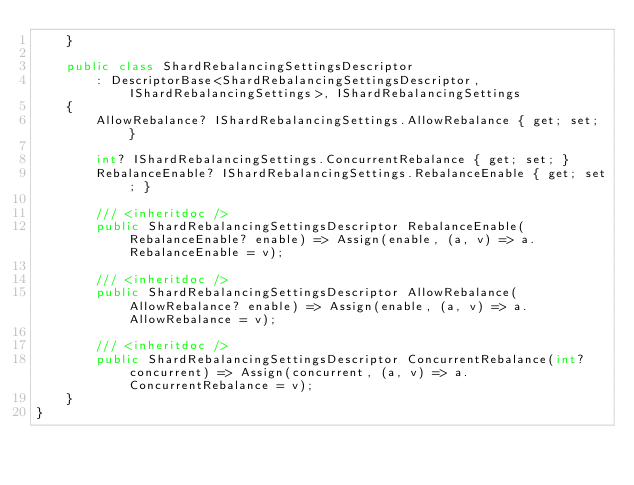<code> <loc_0><loc_0><loc_500><loc_500><_C#_>	}

	public class ShardRebalancingSettingsDescriptor
		: DescriptorBase<ShardRebalancingSettingsDescriptor, IShardRebalancingSettings>, IShardRebalancingSettings
	{
		AllowRebalance? IShardRebalancingSettings.AllowRebalance { get; set; }

		int? IShardRebalancingSettings.ConcurrentRebalance { get; set; }
		RebalanceEnable? IShardRebalancingSettings.RebalanceEnable { get; set; }

		/// <inheritdoc />
		public ShardRebalancingSettingsDescriptor RebalanceEnable(RebalanceEnable? enable) => Assign(enable, (a, v) => a.RebalanceEnable = v);

		/// <inheritdoc />
		public ShardRebalancingSettingsDescriptor AllowRebalance(AllowRebalance? enable) => Assign(enable, (a, v) => a.AllowRebalance = v);

		/// <inheritdoc />
		public ShardRebalancingSettingsDescriptor ConcurrentRebalance(int? concurrent) => Assign(concurrent, (a, v) => a.ConcurrentRebalance = v);
	}
}
</code> 